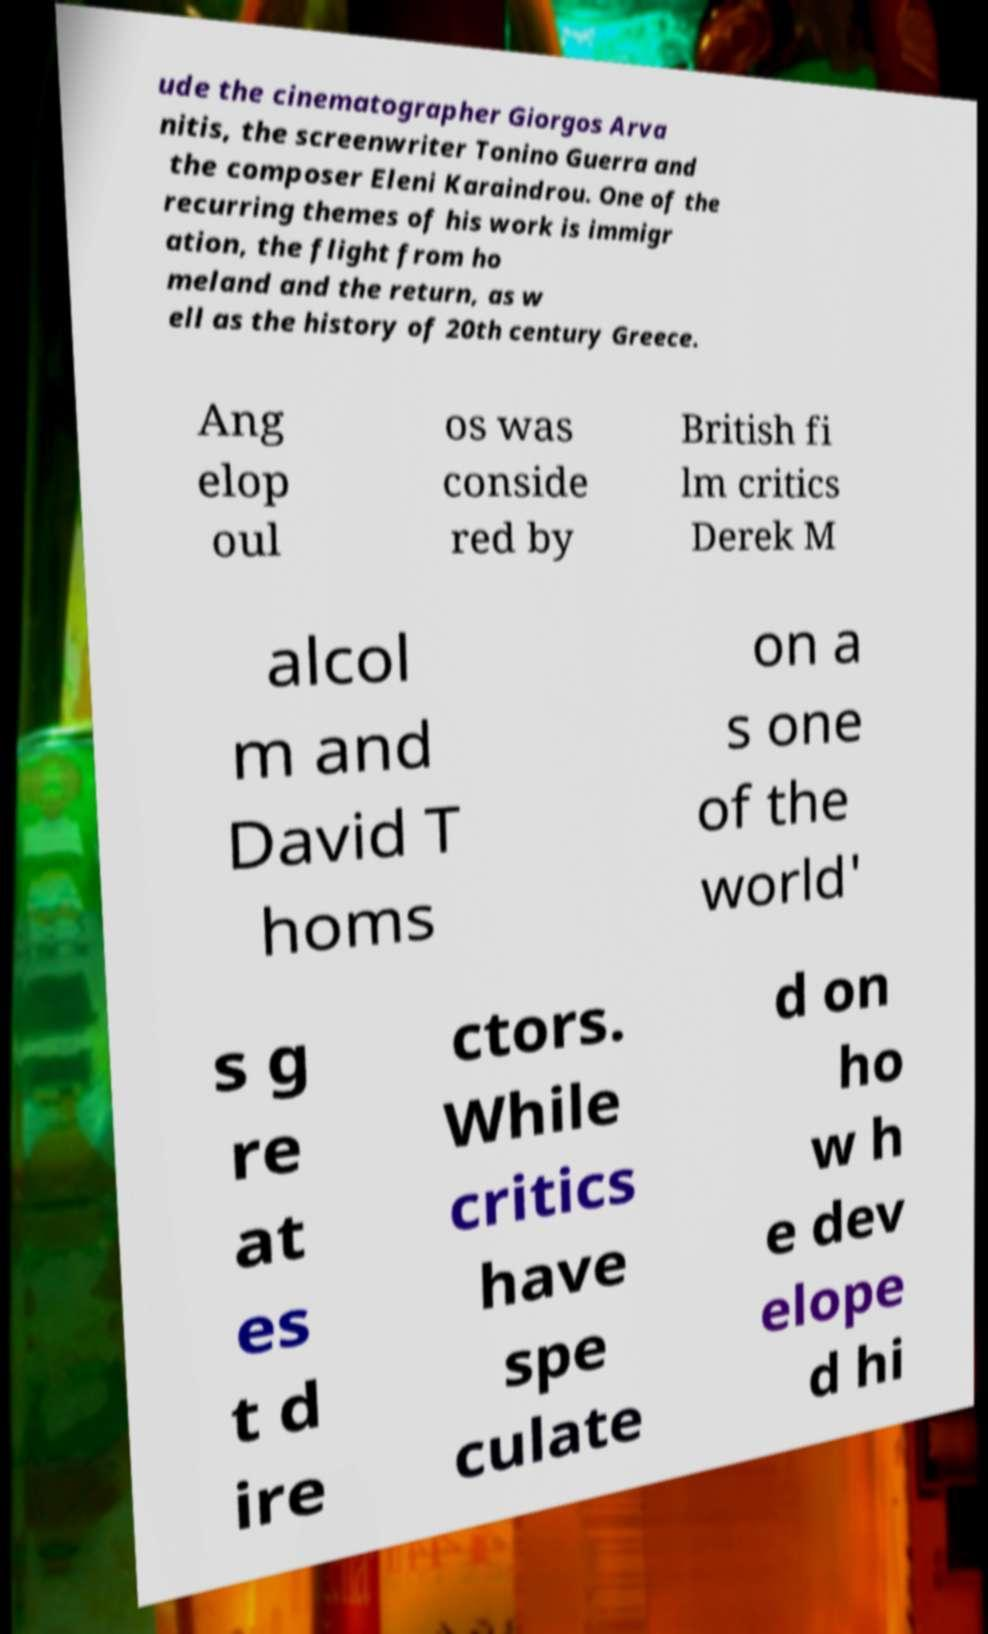What messages or text are displayed in this image? I need them in a readable, typed format. ude the cinematographer Giorgos Arva nitis, the screenwriter Tonino Guerra and the composer Eleni Karaindrou. One of the recurring themes of his work is immigr ation, the flight from ho meland and the return, as w ell as the history of 20th century Greece. Ang elop oul os was conside red by British fi lm critics Derek M alcol m and David T homs on a s one of the world' s g re at es t d ire ctors. While critics have spe culate d on ho w h e dev elope d hi 